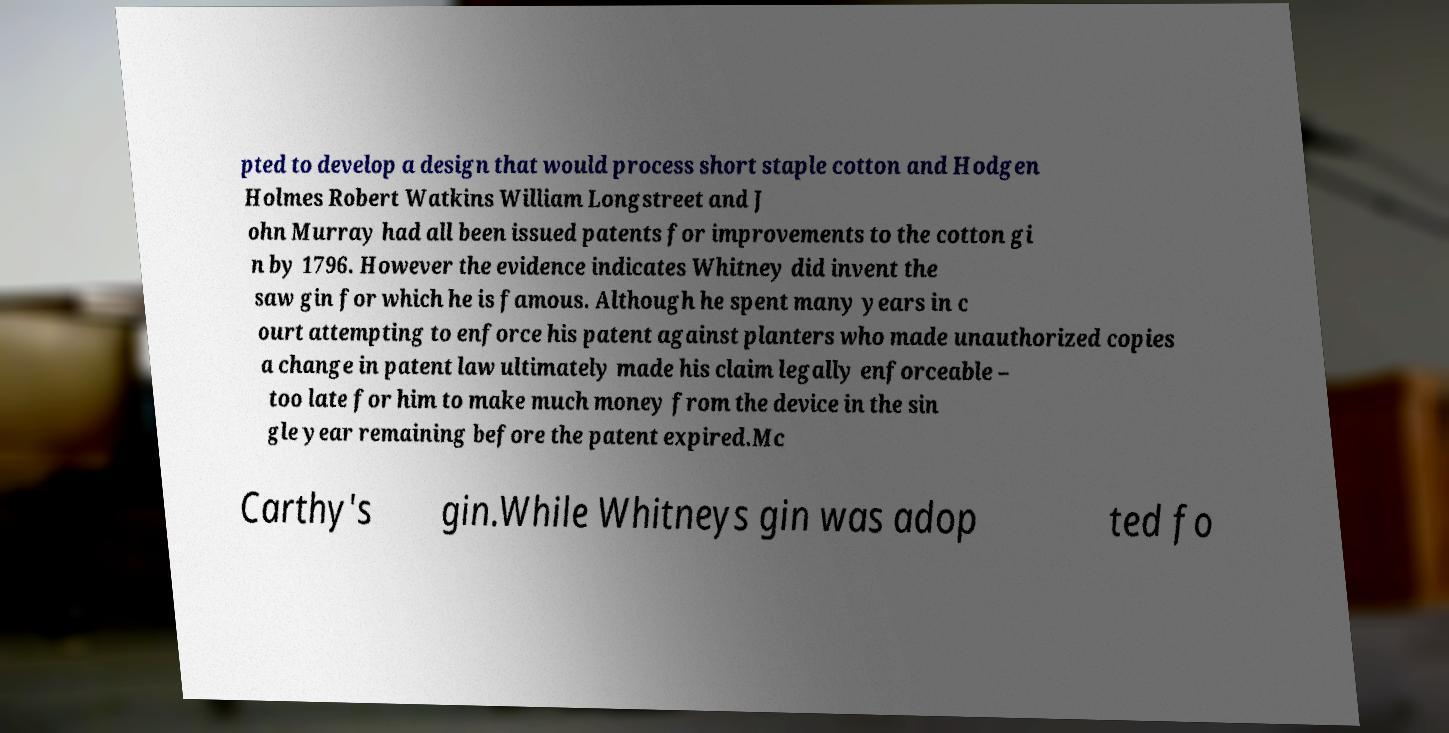Please identify and transcribe the text found in this image. pted to develop a design that would process short staple cotton and Hodgen Holmes Robert Watkins William Longstreet and J ohn Murray had all been issued patents for improvements to the cotton gi n by 1796. However the evidence indicates Whitney did invent the saw gin for which he is famous. Although he spent many years in c ourt attempting to enforce his patent against planters who made unauthorized copies a change in patent law ultimately made his claim legally enforceable – too late for him to make much money from the device in the sin gle year remaining before the patent expired.Mc Carthy's gin.While Whitneys gin was adop ted fo 